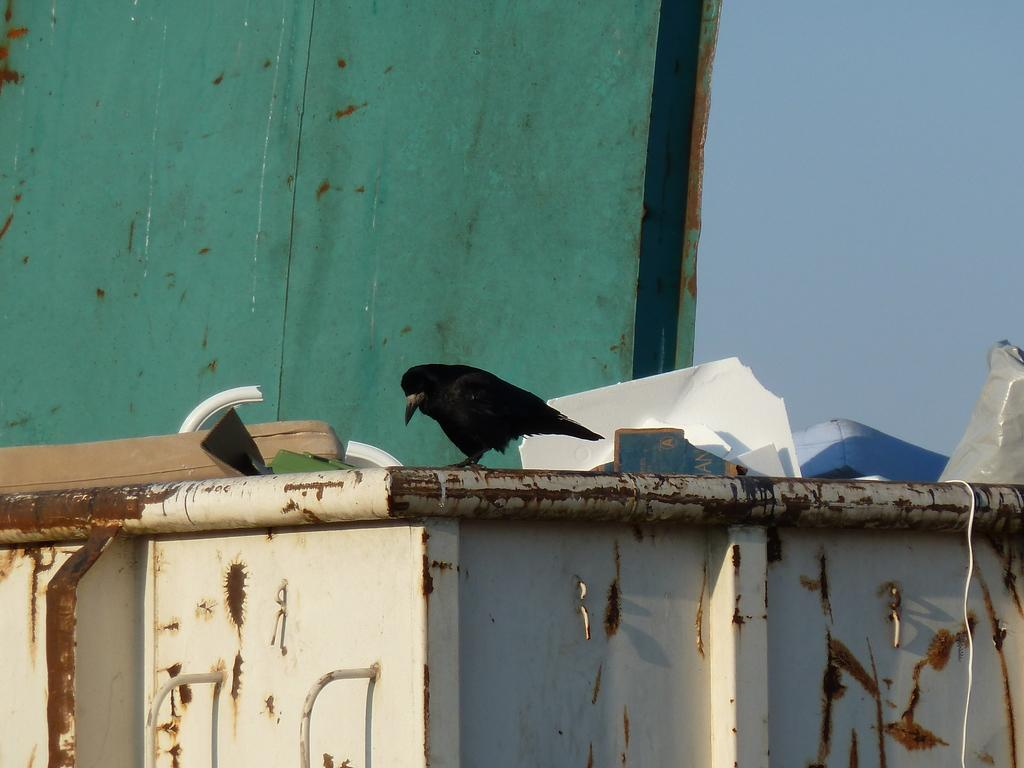What is the main object in the image? There is a table in the image. What is on top of the table? There is a black color bird on the table. What color is the wall in the image? There is a green color wall in the image. What can be seen at the top of the image? The sky is visible at the top of the image. How does the bird use the comb in the image? There is no comb present in the image; it only features a table, a black color bird, a green color wall, and the sky. 